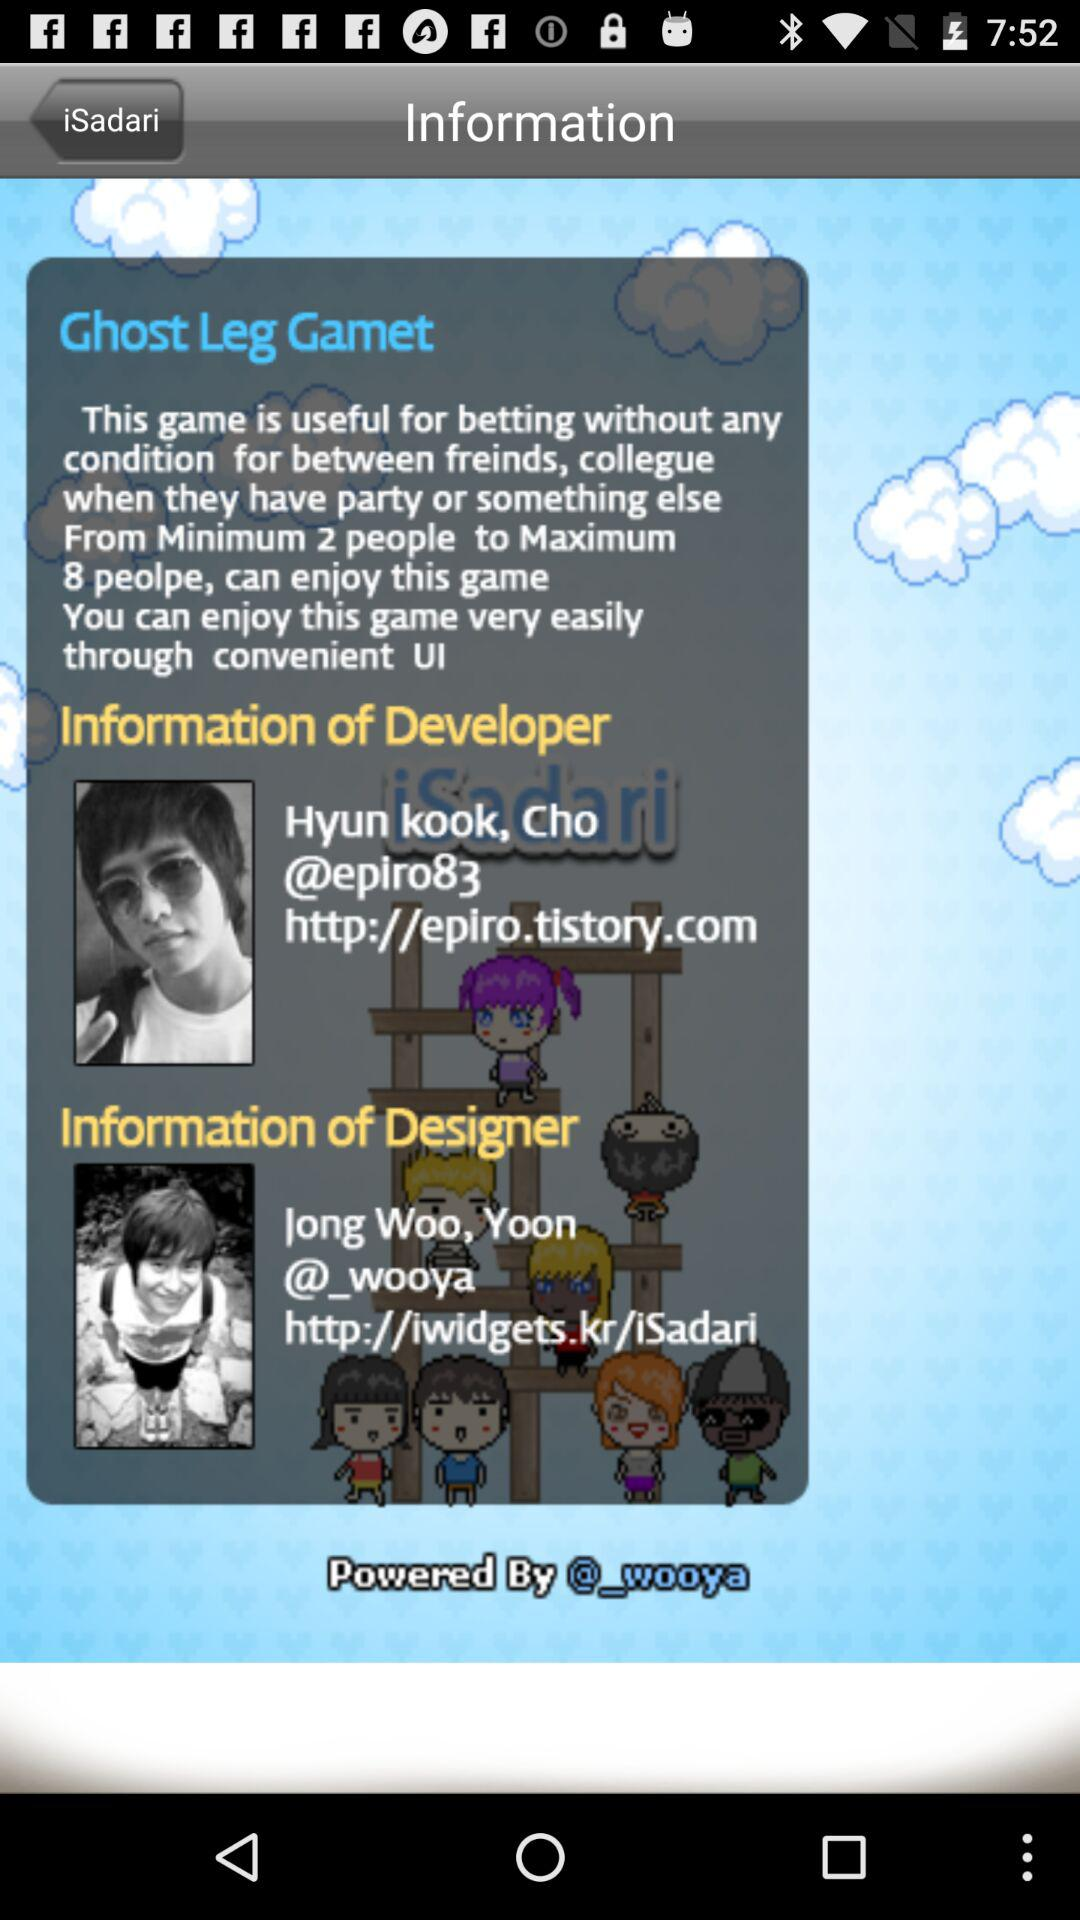What is the information about the developer? The information of the developer is "Hyun kook, Cho@epiro83 http://epiro.tistory.com". 